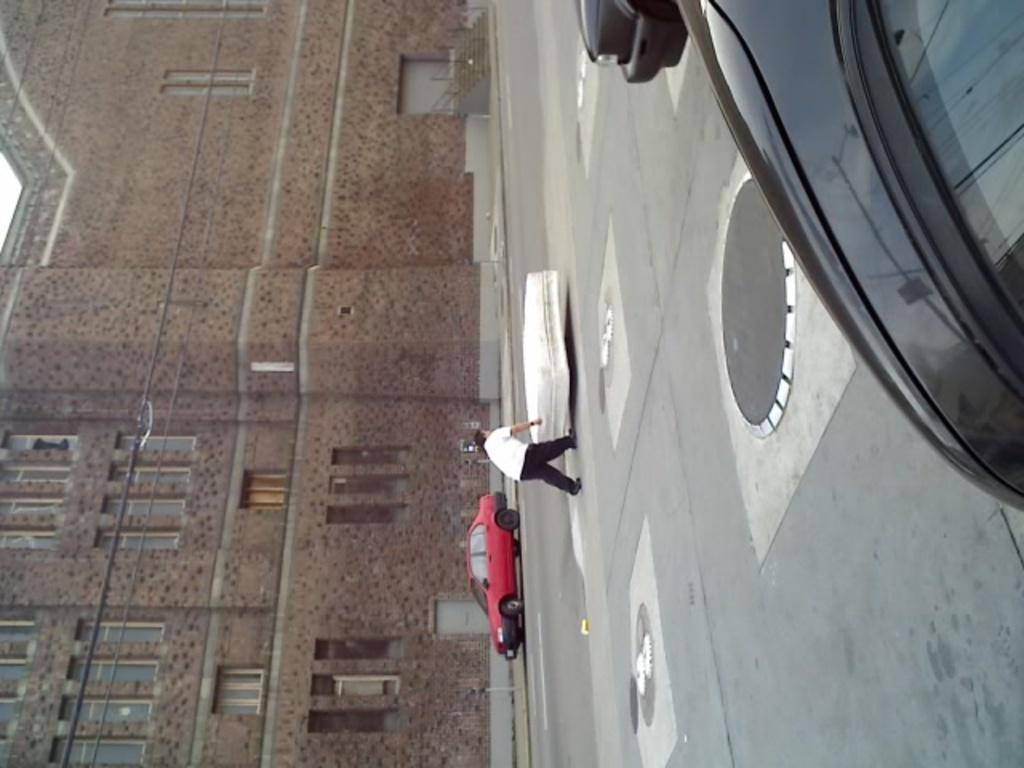What types of objects are present in the image? There are vehicles, a person, and a building in the image. Can you describe the building in the image? The building has windows. What is the person in the image doing? A person is standing beside an object. Are there any seeds visible in the image? There is no mention of seeds in the provided facts, so we cannot determine if any seeds are present in the image. Can you describe the blade in the image? There is no blade mentioned in the provided facts, so we cannot describe a blade in the image. 